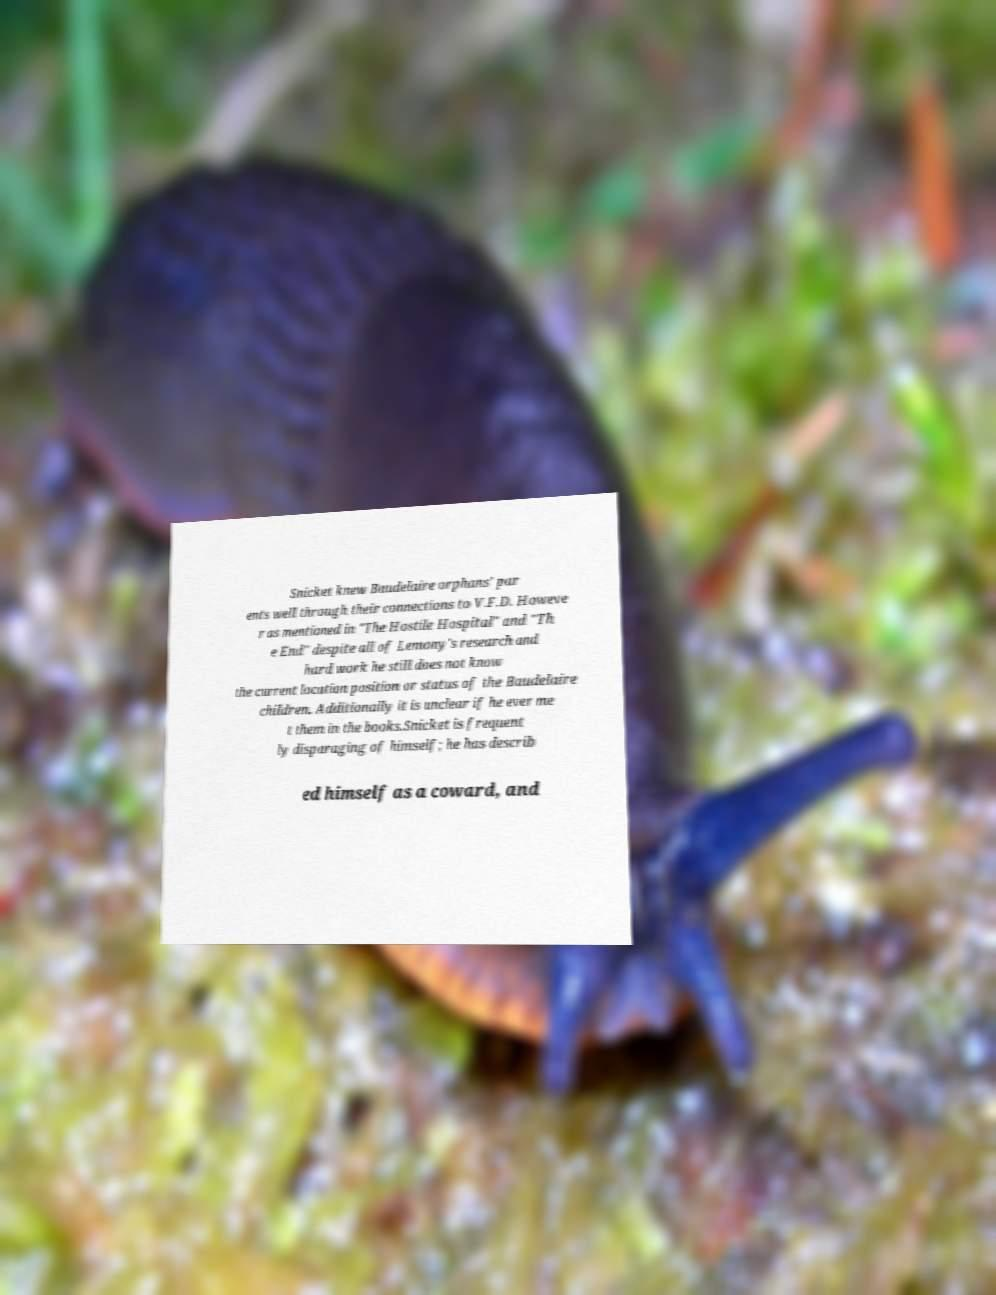Please identify and transcribe the text found in this image. Snicket knew Baudelaire orphans' par ents well through their connections to V.F.D. Howeve r as mentioned in "The Hostile Hospital" and "Th e End" despite all of Lemony's research and hard work he still does not know the current location position or status of the Baudelaire children. Additionally it is unclear if he ever me t them in the books.Snicket is frequent ly disparaging of himself; he has describ ed himself as a coward, and 